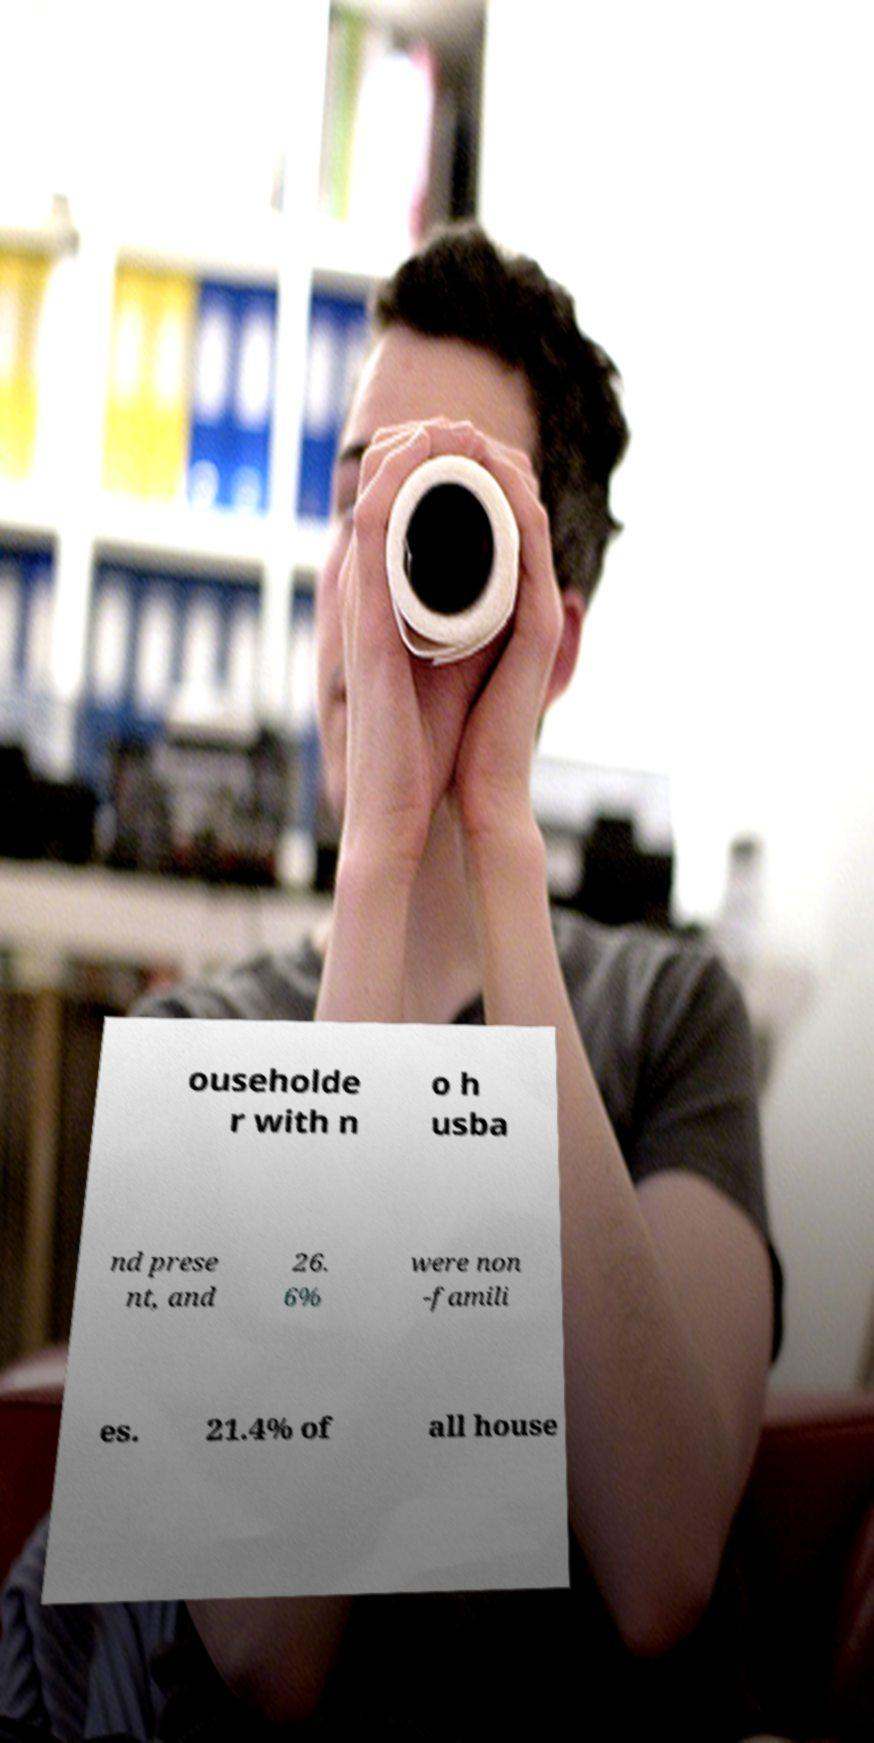For documentation purposes, I need the text within this image transcribed. Could you provide that? ouseholde r with n o h usba nd prese nt, and 26. 6% were non -famili es. 21.4% of all house 